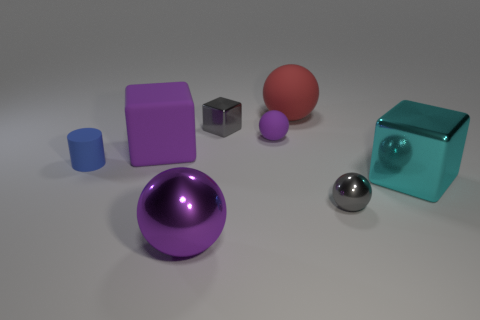Is there any other thing that has the same shape as the blue thing?
Ensure brevity in your answer.  No. How many big things are rubber spheres or gray things?
Your answer should be very brief. 1. What number of purple rubber things are the same shape as the cyan shiny object?
Offer a terse response. 1. There is a large cyan object; is it the same shape as the large metal thing that is on the left side of the small purple object?
Keep it short and to the point. No. How many small gray shiny things are in front of the tiny metallic cube?
Your answer should be compact. 1. Is there a green cube of the same size as the gray block?
Provide a succinct answer. No. Does the gray thing that is in front of the small gray shiny block have the same shape as the big red rubber thing?
Provide a short and direct response. Yes. What is the color of the big metallic block?
Provide a succinct answer. Cyan. What is the shape of the big shiny thing that is the same color as the small matte ball?
Your answer should be compact. Sphere. Are there any tiny shiny spheres?
Offer a terse response. Yes. 